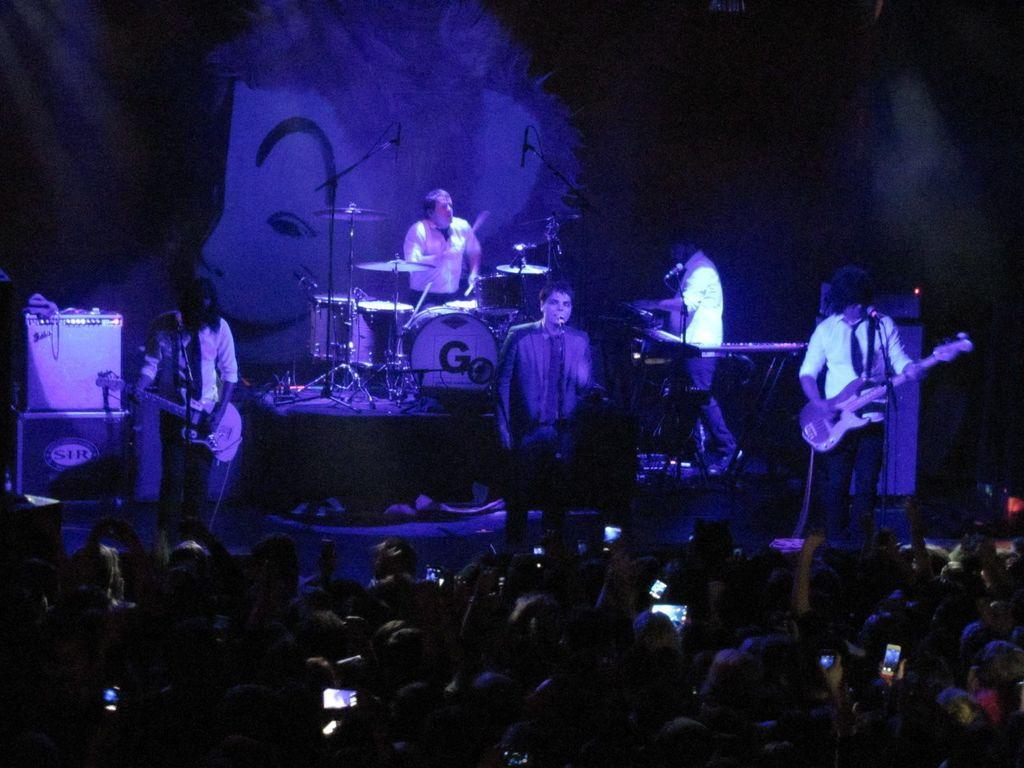In one or two sentences, can you explain what this image depicts? There are group of musicians performing on the stage in this picture. In the background a man is performing in front of the drums. In the right side the man is standing and holding a musical instrument in his hand. At the center a person is standing in front of the mic. In front the crowds are holding a mobile in their hands and performance is being enjoyed by these crowd. In the background there is boxes. 